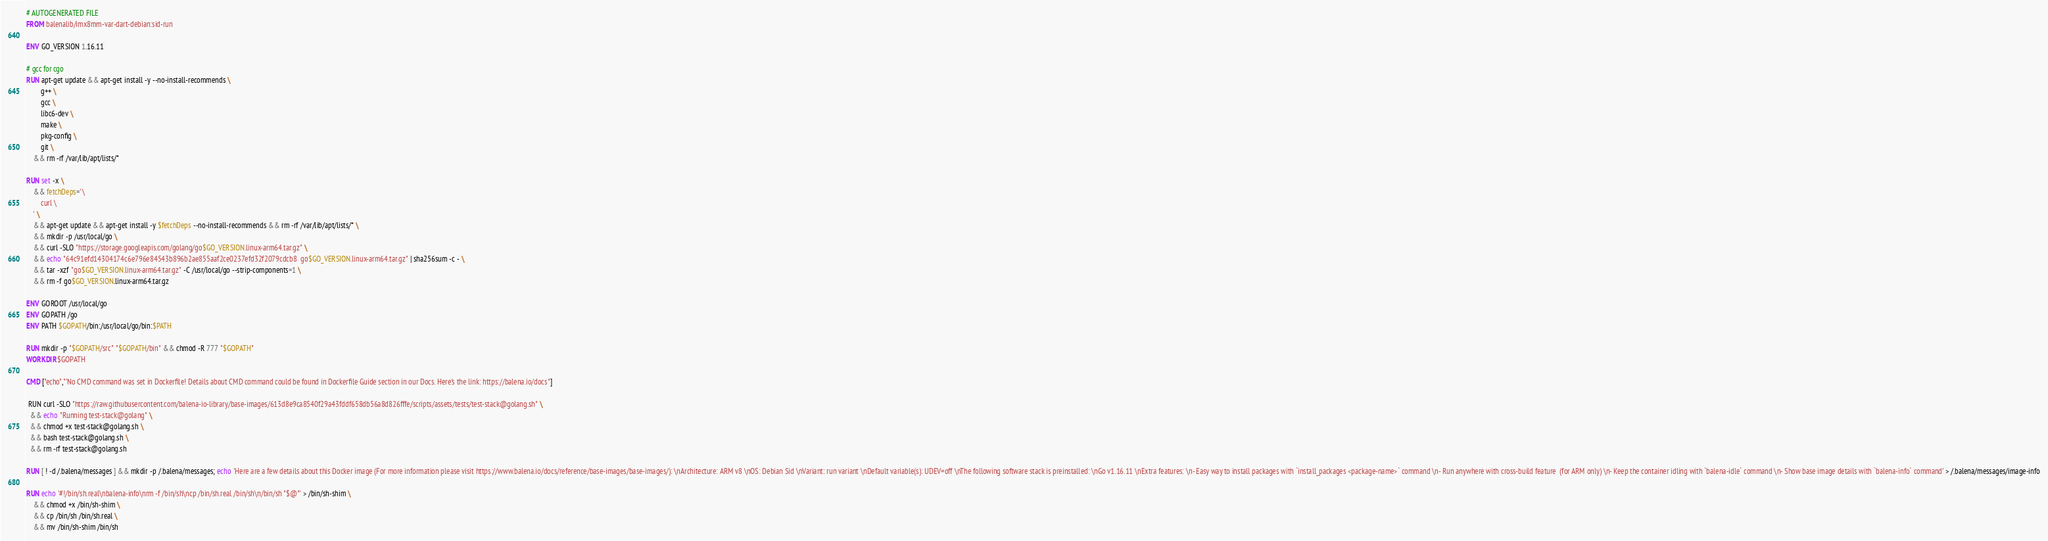Convert code to text. <code><loc_0><loc_0><loc_500><loc_500><_Dockerfile_># AUTOGENERATED FILE
FROM balenalib/imx8mm-var-dart-debian:sid-run

ENV GO_VERSION 1.16.11

# gcc for cgo
RUN apt-get update && apt-get install -y --no-install-recommends \
		g++ \
		gcc \
		libc6-dev \
		make \
		pkg-config \
		git \
	&& rm -rf /var/lib/apt/lists/*

RUN set -x \
	&& fetchDeps=' \
		curl \
	' \
	&& apt-get update && apt-get install -y $fetchDeps --no-install-recommends && rm -rf /var/lib/apt/lists/* \
	&& mkdir -p /usr/local/go \
	&& curl -SLO "https://storage.googleapis.com/golang/go$GO_VERSION.linux-arm64.tar.gz" \
	&& echo "64c91efd14304174c6e796e84543b896b2ae855aaf2ce0237efd32f2079cdcb8  go$GO_VERSION.linux-arm64.tar.gz" | sha256sum -c - \
	&& tar -xzf "go$GO_VERSION.linux-arm64.tar.gz" -C /usr/local/go --strip-components=1 \
	&& rm -f go$GO_VERSION.linux-arm64.tar.gz

ENV GOROOT /usr/local/go
ENV GOPATH /go
ENV PATH $GOPATH/bin:/usr/local/go/bin:$PATH

RUN mkdir -p "$GOPATH/src" "$GOPATH/bin" && chmod -R 777 "$GOPATH"
WORKDIR $GOPATH

CMD ["echo","'No CMD command was set in Dockerfile! Details about CMD command could be found in Dockerfile Guide section in our Docs. Here's the link: https://balena.io/docs"]

 RUN curl -SLO "https://raw.githubusercontent.com/balena-io-library/base-images/613d8e9ca8540f29a43fddf658db56a8d826fffe/scripts/assets/tests/test-stack@golang.sh" \
  && echo "Running test-stack@golang" \
  && chmod +x test-stack@golang.sh \
  && bash test-stack@golang.sh \
  && rm -rf test-stack@golang.sh 

RUN [ ! -d /.balena/messages ] && mkdir -p /.balena/messages; echo 'Here are a few details about this Docker image (For more information please visit https://www.balena.io/docs/reference/base-images/base-images/): \nArchitecture: ARM v8 \nOS: Debian Sid \nVariant: run variant \nDefault variable(s): UDEV=off \nThe following software stack is preinstalled: \nGo v1.16.11 \nExtra features: \n- Easy way to install packages with `install_packages <package-name>` command \n- Run anywhere with cross-build feature  (for ARM only) \n- Keep the container idling with `balena-idle` command \n- Show base image details with `balena-info` command' > /.balena/messages/image-info

RUN echo '#!/bin/sh.real\nbalena-info\nrm -f /bin/sh\ncp /bin/sh.real /bin/sh\n/bin/sh "$@"' > /bin/sh-shim \
	&& chmod +x /bin/sh-shim \
	&& cp /bin/sh /bin/sh.real \
	&& mv /bin/sh-shim /bin/sh</code> 